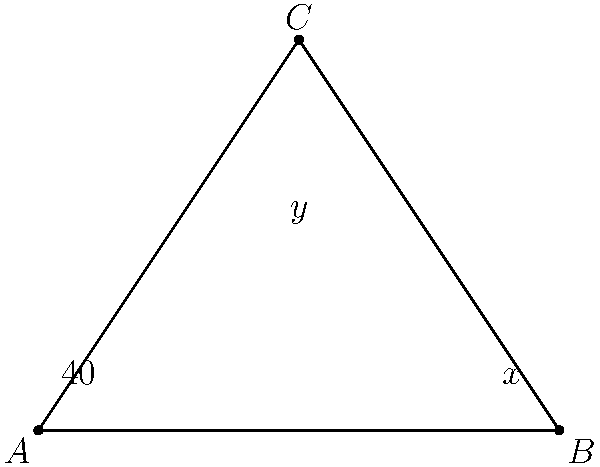In a Shakespearean theater, two stage curtains intersect to form a triangular opening. If one of the angles formed by the curtains is $40°$ and the angle at the top of the opening is $y°$, what is the value of $x°$? Let's approach this step-by-step:

1) In any triangle, the sum of all interior angles is always $180°$.

2) Let's call the three angles of our triangle $40°$, $x°$, and $y°$.

3) We can write an equation based on the fact that these three angles must sum to $180°$:

   $40° + x° + y° = 180°$

4) We also know that the two angles at the base of the triangle (formed by the curtains) are supplementary, meaning they add up to $180°$:

   $40° + x° = 180°$

5) From this second equation, we can directly solve for $x°$:

   $x° = 180° - 40° = 140°$

This solution reflects the symmetry often found in theatrical designs, reminiscent of the balanced structures in Shakespeare's plays.
Answer: $140°$ 